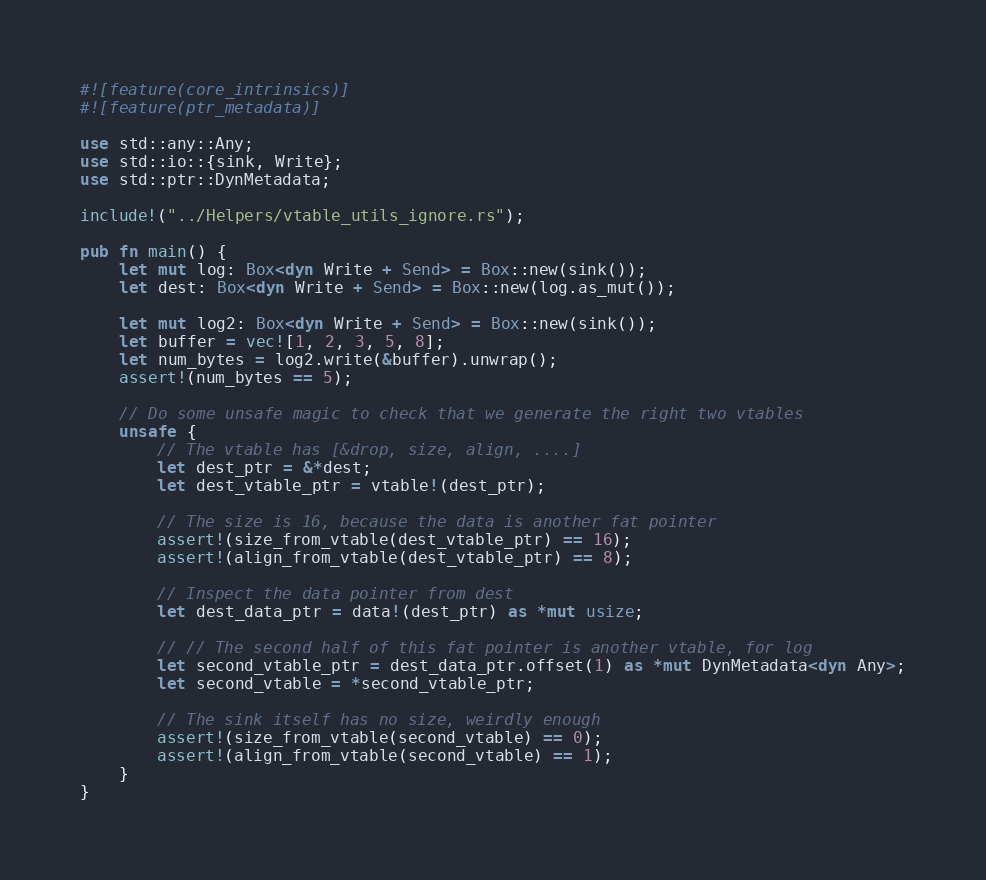Convert code to text. <code><loc_0><loc_0><loc_500><loc_500><_Rust_>#![feature(core_intrinsics)]
#![feature(ptr_metadata)]

use std::any::Any;
use std::io::{sink, Write};
use std::ptr::DynMetadata;

include!("../Helpers/vtable_utils_ignore.rs");

pub fn main() {
    let mut log: Box<dyn Write + Send> = Box::new(sink());
    let dest: Box<dyn Write + Send> = Box::new(log.as_mut());

    let mut log2: Box<dyn Write + Send> = Box::new(sink());
    let buffer = vec![1, 2, 3, 5, 8];
    let num_bytes = log2.write(&buffer).unwrap();
    assert!(num_bytes == 5);

    // Do some unsafe magic to check that we generate the right two vtables
    unsafe {
        // The vtable has [&drop, size, align, ....]
        let dest_ptr = &*dest;
        let dest_vtable_ptr = vtable!(dest_ptr);

        // The size is 16, because the data is another fat pointer
        assert!(size_from_vtable(dest_vtable_ptr) == 16);
        assert!(align_from_vtable(dest_vtable_ptr) == 8);

        // Inspect the data pointer from dest
        let dest_data_ptr = data!(dest_ptr) as *mut usize;

        // // The second half of this fat pointer is another vtable, for log
        let second_vtable_ptr = dest_data_ptr.offset(1) as *mut DynMetadata<dyn Any>;
        let second_vtable = *second_vtable_ptr;

        // The sink itself has no size, weirdly enough
        assert!(size_from_vtable(second_vtable) == 0);
        assert!(align_from_vtable(second_vtable) == 1);
    }
}
</code> 